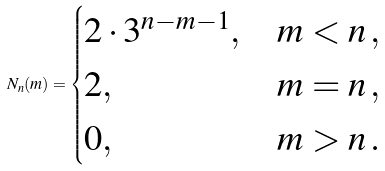<formula> <loc_0><loc_0><loc_500><loc_500>N _ { n } ( m ) = \begin{cases} 2 \cdot 3 ^ { n - m - 1 } , & m < n \, , \\ 2 , & m = n \, , \\ 0 , & m > n \, . \end{cases}</formula> 